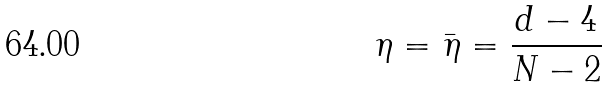<formula> <loc_0><loc_0><loc_500><loc_500>\eta = \bar { \eta } = \frac { d - 4 } { N - 2 }</formula> 